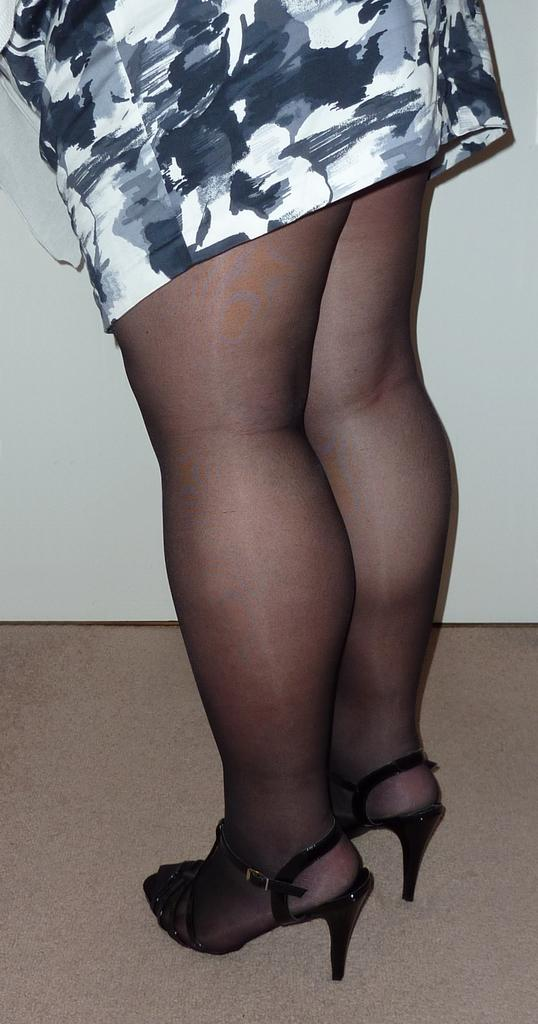What is the main subject of the image? There is a person in the image. Can you describe the person's footwear? The person is wearing footwear. What colors are used in the person's dress? The person's dress is in white, black, and grey colors. What is the color of the background in the image? The background of the image is white. What type of substance is being used by the insect in the image? There is no insect present in the image, so it is not possible to determine what substance might be used by an insect. 